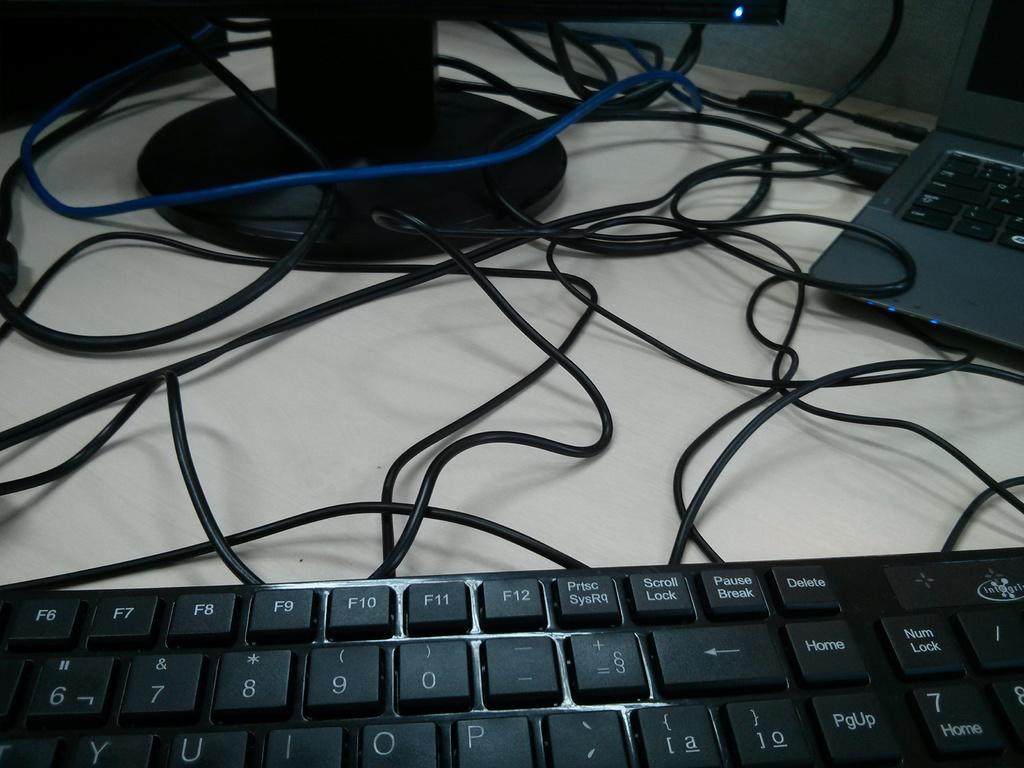Provide a one-sentence caption for the provided image. A keybord is in the foreground, on which the delete key is to the right of the pause break key. 